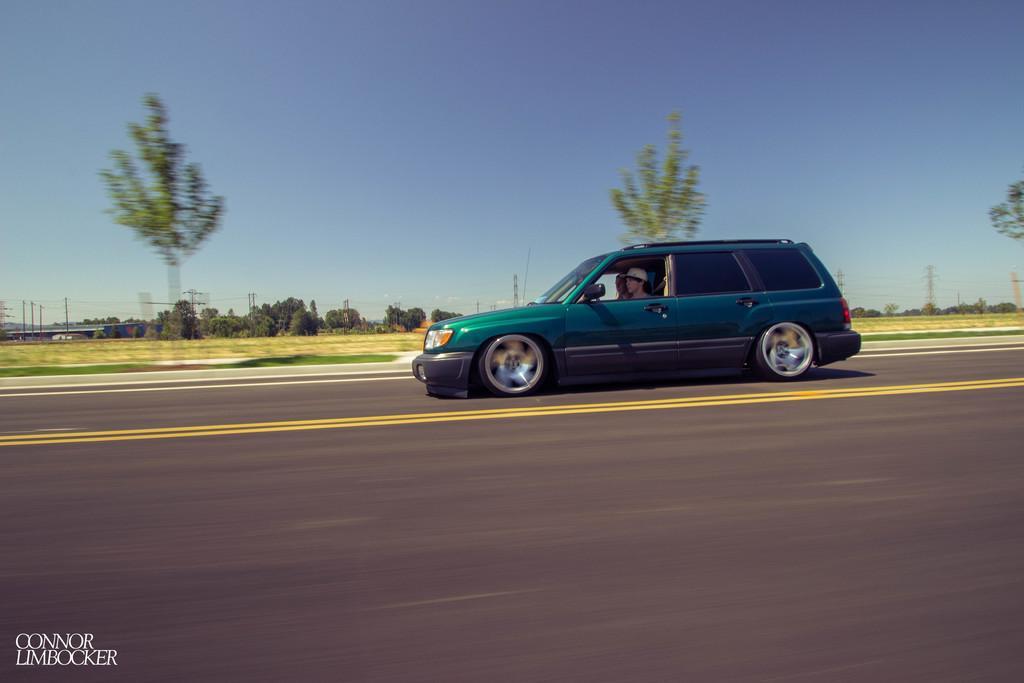Please provide a concise description of this image. In this image I can see the vehicle and I can see two persons sitting in the vehicle. In the background I can see few trees, electric poles and the sky is in blue and white color. 